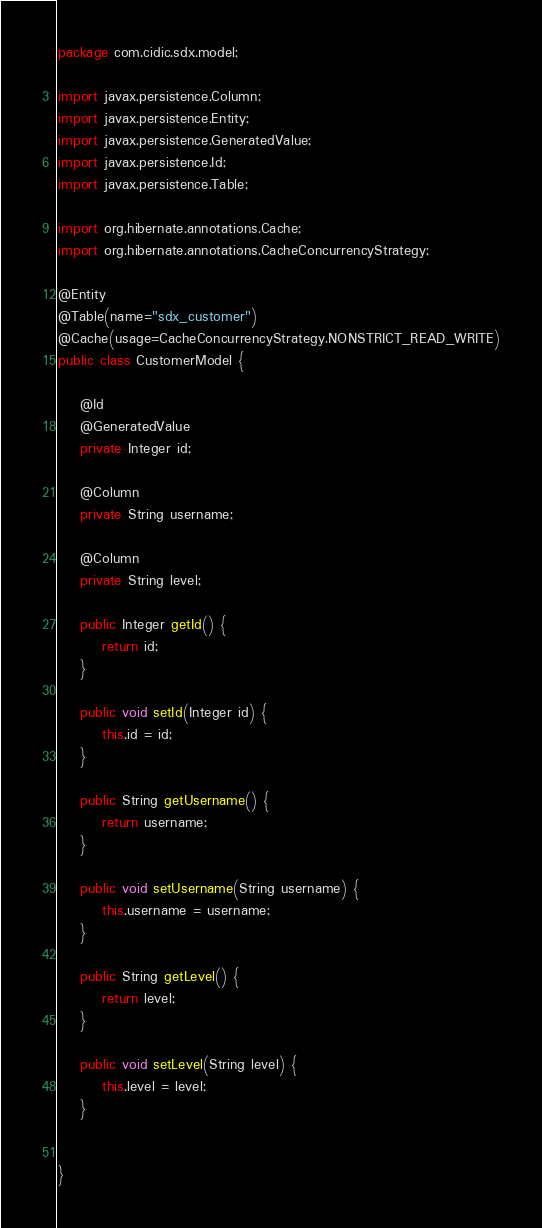Convert code to text. <code><loc_0><loc_0><loc_500><loc_500><_Java_>package com.cidic.sdx.model;

import javax.persistence.Column;
import javax.persistence.Entity;
import javax.persistence.GeneratedValue;
import javax.persistence.Id;
import javax.persistence.Table;

import org.hibernate.annotations.Cache;
import org.hibernate.annotations.CacheConcurrencyStrategy;

@Entity
@Table(name="sdx_customer")
@Cache(usage=CacheConcurrencyStrategy.NONSTRICT_READ_WRITE)
public class CustomerModel {
	
	@Id
	@GeneratedValue
	private Integer id;
	
	@Column
	private String username;
	
	@Column
	private String level;

	public Integer getId() {
		return id;
	}

	public void setId(Integer id) {
		this.id = id;
	}

	public String getUsername() {
		return username;
	}

	public void setUsername(String username) {
		this.username = username;
	}

	public String getLevel() {
		return level;
	}

	public void setLevel(String level) {
		this.level = level;
	}
	
	
}
</code> 